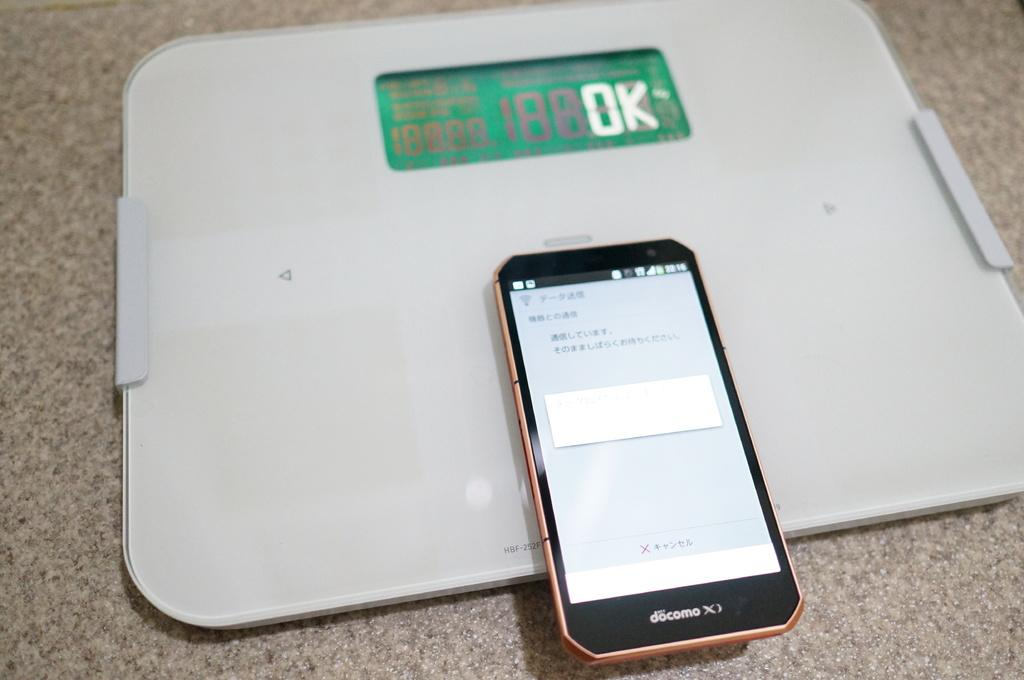What type of device is in the image? There is a weighing machine in the image. What other object can be seen in the image? There is a mobile phone in the image. Where are the objects located in the image? Both objects are on a surface. What type of letters can be seen on the weighing machine in the image? There are no letters visible on the weighing machine in the image. Can you tell me how much credit is available on the mobile phone in the image? There is no information about the credit available on the mobile phone in the image. 